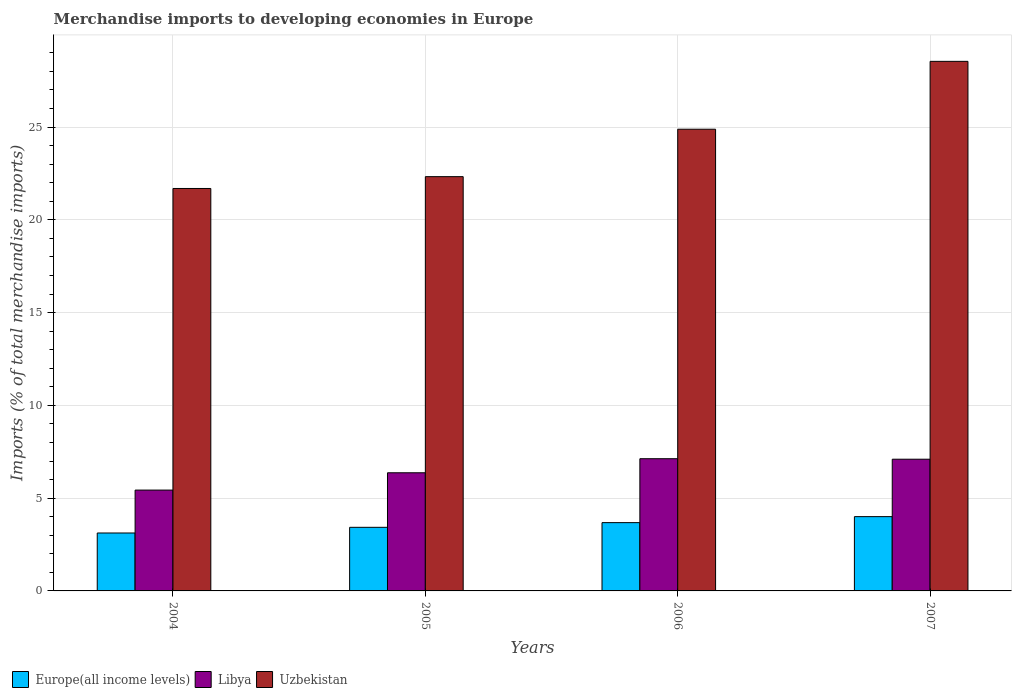How many different coloured bars are there?
Make the answer very short. 3. Are the number of bars per tick equal to the number of legend labels?
Your answer should be very brief. Yes. How many bars are there on the 1st tick from the left?
Your answer should be very brief. 3. What is the label of the 2nd group of bars from the left?
Give a very brief answer. 2005. In how many cases, is the number of bars for a given year not equal to the number of legend labels?
Your answer should be very brief. 0. What is the percentage total merchandise imports in Libya in 2005?
Your response must be concise. 6.37. Across all years, what is the maximum percentage total merchandise imports in Libya?
Offer a very short reply. 7.13. Across all years, what is the minimum percentage total merchandise imports in Libya?
Your answer should be very brief. 5.44. In which year was the percentage total merchandise imports in Uzbekistan maximum?
Offer a very short reply. 2007. In which year was the percentage total merchandise imports in Libya minimum?
Your answer should be compact. 2004. What is the total percentage total merchandise imports in Uzbekistan in the graph?
Your answer should be very brief. 97.45. What is the difference between the percentage total merchandise imports in Libya in 2004 and that in 2005?
Keep it short and to the point. -0.93. What is the difference between the percentage total merchandise imports in Europe(all income levels) in 2006 and the percentage total merchandise imports in Libya in 2004?
Provide a succinct answer. -1.75. What is the average percentage total merchandise imports in Europe(all income levels) per year?
Keep it short and to the point. 3.56. In the year 2006, what is the difference between the percentage total merchandise imports in Uzbekistan and percentage total merchandise imports in Libya?
Your answer should be very brief. 17.76. What is the ratio of the percentage total merchandise imports in Libya in 2005 to that in 2006?
Keep it short and to the point. 0.89. Is the difference between the percentage total merchandise imports in Uzbekistan in 2004 and 2007 greater than the difference between the percentage total merchandise imports in Libya in 2004 and 2007?
Offer a very short reply. No. What is the difference between the highest and the second highest percentage total merchandise imports in Europe(all income levels)?
Keep it short and to the point. 0.32. What is the difference between the highest and the lowest percentage total merchandise imports in Europe(all income levels)?
Make the answer very short. 0.88. In how many years, is the percentage total merchandise imports in Uzbekistan greater than the average percentage total merchandise imports in Uzbekistan taken over all years?
Make the answer very short. 2. Is the sum of the percentage total merchandise imports in Uzbekistan in 2004 and 2005 greater than the maximum percentage total merchandise imports in Europe(all income levels) across all years?
Keep it short and to the point. Yes. What does the 1st bar from the left in 2004 represents?
Your response must be concise. Europe(all income levels). What does the 2nd bar from the right in 2004 represents?
Your response must be concise. Libya. Is it the case that in every year, the sum of the percentage total merchandise imports in Europe(all income levels) and percentage total merchandise imports in Libya is greater than the percentage total merchandise imports in Uzbekistan?
Your answer should be very brief. No. Are all the bars in the graph horizontal?
Offer a very short reply. No. How many years are there in the graph?
Provide a short and direct response. 4. Does the graph contain any zero values?
Your answer should be very brief. No. What is the title of the graph?
Provide a short and direct response. Merchandise imports to developing economies in Europe. What is the label or title of the X-axis?
Give a very brief answer. Years. What is the label or title of the Y-axis?
Your answer should be very brief. Imports (% of total merchandise imports). What is the Imports (% of total merchandise imports) of Europe(all income levels) in 2004?
Provide a short and direct response. 3.12. What is the Imports (% of total merchandise imports) in Libya in 2004?
Give a very brief answer. 5.44. What is the Imports (% of total merchandise imports) of Uzbekistan in 2004?
Offer a terse response. 21.69. What is the Imports (% of total merchandise imports) in Europe(all income levels) in 2005?
Keep it short and to the point. 3.43. What is the Imports (% of total merchandise imports) in Libya in 2005?
Keep it short and to the point. 6.37. What is the Imports (% of total merchandise imports) of Uzbekistan in 2005?
Your response must be concise. 22.33. What is the Imports (% of total merchandise imports) in Europe(all income levels) in 2006?
Keep it short and to the point. 3.68. What is the Imports (% of total merchandise imports) of Libya in 2006?
Provide a short and direct response. 7.13. What is the Imports (% of total merchandise imports) of Uzbekistan in 2006?
Ensure brevity in your answer.  24.88. What is the Imports (% of total merchandise imports) of Europe(all income levels) in 2007?
Give a very brief answer. 4. What is the Imports (% of total merchandise imports) in Libya in 2007?
Keep it short and to the point. 7.1. What is the Imports (% of total merchandise imports) of Uzbekistan in 2007?
Your answer should be very brief. 28.54. Across all years, what is the maximum Imports (% of total merchandise imports) of Europe(all income levels)?
Offer a very short reply. 4. Across all years, what is the maximum Imports (% of total merchandise imports) of Libya?
Ensure brevity in your answer.  7.13. Across all years, what is the maximum Imports (% of total merchandise imports) of Uzbekistan?
Make the answer very short. 28.54. Across all years, what is the minimum Imports (% of total merchandise imports) of Europe(all income levels)?
Make the answer very short. 3.12. Across all years, what is the minimum Imports (% of total merchandise imports) in Libya?
Keep it short and to the point. 5.44. Across all years, what is the minimum Imports (% of total merchandise imports) in Uzbekistan?
Make the answer very short. 21.69. What is the total Imports (% of total merchandise imports) in Europe(all income levels) in the graph?
Offer a terse response. 14.23. What is the total Imports (% of total merchandise imports) in Libya in the graph?
Offer a very short reply. 26.03. What is the total Imports (% of total merchandise imports) of Uzbekistan in the graph?
Provide a short and direct response. 97.45. What is the difference between the Imports (% of total merchandise imports) in Europe(all income levels) in 2004 and that in 2005?
Offer a very short reply. -0.31. What is the difference between the Imports (% of total merchandise imports) of Libya in 2004 and that in 2005?
Keep it short and to the point. -0.93. What is the difference between the Imports (% of total merchandise imports) of Uzbekistan in 2004 and that in 2005?
Give a very brief answer. -0.64. What is the difference between the Imports (% of total merchandise imports) of Europe(all income levels) in 2004 and that in 2006?
Make the answer very short. -0.56. What is the difference between the Imports (% of total merchandise imports) of Libya in 2004 and that in 2006?
Offer a terse response. -1.69. What is the difference between the Imports (% of total merchandise imports) of Uzbekistan in 2004 and that in 2006?
Offer a terse response. -3.19. What is the difference between the Imports (% of total merchandise imports) of Europe(all income levels) in 2004 and that in 2007?
Keep it short and to the point. -0.88. What is the difference between the Imports (% of total merchandise imports) of Libya in 2004 and that in 2007?
Your answer should be very brief. -1.66. What is the difference between the Imports (% of total merchandise imports) of Uzbekistan in 2004 and that in 2007?
Provide a succinct answer. -6.85. What is the difference between the Imports (% of total merchandise imports) in Europe(all income levels) in 2005 and that in 2006?
Offer a terse response. -0.25. What is the difference between the Imports (% of total merchandise imports) of Libya in 2005 and that in 2006?
Ensure brevity in your answer.  -0.76. What is the difference between the Imports (% of total merchandise imports) in Uzbekistan in 2005 and that in 2006?
Offer a terse response. -2.56. What is the difference between the Imports (% of total merchandise imports) of Europe(all income levels) in 2005 and that in 2007?
Keep it short and to the point. -0.58. What is the difference between the Imports (% of total merchandise imports) of Libya in 2005 and that in 2007?
Make the answer very short. -0.73. What is the difference between the Imports (% of total merchandise imports) in Uzbekistan in 2005 and that in 2007?
Offer a very short reply. -6.21. What is the difference between the Imports (% of total merchandise imports) in Europe(all income levels) in 2006 and that in 2007?
Your answer should be compact. -0.32. What is the difference between the Imports (% of total merchandise imports) in Libya in 2006 and that in 2007?
Offer a terse response. 0.03. What is the difference between the Imports (% of total merchandise imports) of Uzbekistan in 2006 and that in 2007?
Your response must be concise. -3.66. What is the difference between the Imports (% of total merchandise imports) of Europe(all income levels) in 2004 and the Imports (% of total merchandise imports) of Libya in 2005?
Give a very brief answer. -3.25. What is the difference between the Imports (% of total merchandise imports) of Europe(all income levels) in 2004 and the Imports (% of total merchandise imports) of Uzbekistan in 2005?
Give a very brief answer. -19.21. What is the difference between the Imports (% of total merchandise imports) in Libya in 2004 and the Imports (% of total merchandise imports) in Uzbekistan in 2005?
Provide a short and direct response. -16.89. What is the difference between the Imports (% of total merchandise imports) of Europe(all income levels) in 2004 and the Imports (% of total merchandise imports) of Libya in 2006?
Offer a terse response. -4. What is the difference between the Imports (% of total merchandise imports) of Europe(all income levels) in 2004 and the Imports (% of total merchandise imports) of Uzbekistan in 2006?
Provide a succinct answer. -21.76. What is the difference between the Imports (% of total merchandise imports) of Libya in 2004 and the Imports (% of total merchandise imports) of Uzbekistan in 2006?
Give a very brief answer. -19.45. What is the difference between the Imports (% of total merchandise imports) in Europe(all income levels) in 2004 and the Imports (% of total merchandise imports) in Libya in 2007?
Ensure brevity in your answer.  -3.98. What is the difference between the Imports (% of total merchandise imports) of Europe(all income levels) in 2004 and the Imports (% of total merchandise imports) of Uzbekistan in 2007?
Give a very brief answer. -25.42. What is the difference between the Imports (% of total merchandise imports) in Libya in 2004 and the Imports (% of total merchandise imports) in Uzbekistan in 2007?
Give a very brief answer. -23.11. What is the difference between the Imports (% of total merchandise imports) of Europe(all income levels) in 2005 and the Imports (% of total merchandise imports) of Libya in 2006?
Give a very brief answer. -3.7. What is the difference between the Imports (% of total merchandise imports) of Europe(all income levels) in 2005 and the Imports (% of total merchandise imports) of Uzbekistan in 2006?
Make the answer very short. -21.46. What is the difference between the Imports (% of total merchandise imports) in Libya in 2005 and the Imports (% of total merchandise imports) in Uzbekistan in 2006?
Provide a short and direct response. -18.52. What is the difference between the Imports (% of total merchandise imports) in Europe(all income levels) in 2005 and the Imports (% of total merchandise imports) in Libya in 2007?
Ensure brevity in your answer.  -3.67. What is the difference between the Imports (% of total merchandise imports) of Europe(all income levels) in 2005 and the Imports (% of total merchandise imports) of Uzbekistan in 2007?
Make the answer very short. -25.11. What is the difference between the Imports (% of total merchandise imports) in Libya in 2005 and the Imports (% of total merchandise imports) in Uzbekistan in 2007?
Give a very brief answer. -22.17. What is the difference between the Imports (% of total merchandise imports) of Europe(all income levels) in 2006 and the Imports (% of total merchandise imports) of Libya in 2007?
Offer a terse response. -3.42. What is the difference between the Imports (% of total merchandise imports) of Europe(all income levels) in 2006 and the Imports (% of total merchandise imports) of Uzbekistan in 2007?
Provide a succinct answer. -24.86. What is the difference between the Imports (% of total merchandise imports) in Libya in 2006 and the Imports (% of total merchandise imports) in Uzbekistan in 2007?
Ensure brevity in your answer.  -21.42. What is the average Imports (% of total merchandise imports) of Europe(all income levels) per year?
Make the answer very short. 3.56. What is the average Imports (% of total merchandise imports) in Libya per year?
Keep it short and to the point. 6.51. What is the average Imports (% of total merchandise imports) of Uzbekistan per year?
Provide a succinct answer. 24.36. In the year 2004, what is the difference between the Imports (% of total merchandise imports) of Europe(all income levels) and Imports (% of total merchandise imports) of Libya?
Your answer should be very brief. -2.31. In the year 2004, what is the difference between the Imports (% of total merchandise imports) of Europe(all income levels) and Imports (% of total merchandise imports) of Uzbekistan?
Make the answer very short. -18.57. In the year 2004, what is the difference between the Imports (% of total merchandise imports) of Libya and Imports (% of total merchandise imports) of Uzbekistan?
Provide a short and direct response. -16.26. In the year 2005, what is the difference between the Imports (% of total merchandise imports) in Europe(all income levels) and Imports (% of total merchandise imports) in Libya?
Keep it short and to the point. -2.94. In the year 2005, what is the difference between the Imports (% of total merchandise imports) of Europe(all income levels) and Imports (% of total merchandise imports) of Uzbekistan?
Offer a very short reply. -18.9. In the year 2005, what is the difference between the Imports (% of total merchandise imports) of Libya and Imports (% of total merchandise imports) of Uzbekistan?
Keep it short and to the point. -15.96. In the year 2006, what is the difference between the Imports (% of total merchandise imports) in Europe(all income levels) and Imports (% of total merchandise imports) in Libya?
Your answer should be compact. -3.44. In the year 2006, what is the difference between the Imports (% of total merchandise imports) of Europe(all income levels) and Imports (% of total merchandise imports) of Uzbekistan?
Provide a succinct answer. -21.2. In the year 2006, what is the difference between the Imports (% of total merchandise imports) of Libya and Imports (% of total merchandise imports) of Uzbekistan?
Make the answer very short. -17.76. In the year 2007, what is the difference between the Imports (% of total merchandise imports) of Europe(all income levels) and Imports (% of total merchandise imports) of Libya?
Your response must be concise. -3.09. In the year 2007, what is the difference between the Imports (% of total merchandise imports) in Europe(all income levels) and Imports (% of total merchandise imports) in Uzbekistan?
Make the answer very short. -24.54. In the year 2007, what is the difference between the Imports (% of total merchandise imports) of Libya and Imports (% of total merchandise imports) of Uzbekistan?
Keep it short and to the point. -21.44. What is the ratio of the Imports (% of total merchandise imports) in Europe(all income levels) in 2004 to that in 2005?
Provide a short and direct response. 0.91. What is the ratio of the Imports (% of total merchandise imports) in Libya in 2004 to that in 2005?
Offer a very short reply. 0.85. What is the ratio of the Imports (% of total merchandise imports) in Uzbekistan in 2004 to that in 2005?
Make the answer very short. 0.97. What is the ratio of the Imports (% of total merchandise imports) in Europe(all income levels) in 2004 to that in 2006?
Provide a succinct answer. 0.85. What is the ratio of the Imports (% of total merchandise imports) in Libya in 2004 to that in 2006?
Your answer should be very brief. 0.76. What is the ratio of the Imports (% of total merchandise imports) of Uzbekistan in 2004 to that in 2006?
Provide a short and direct response. 0.87. What is the ratio of the Imports (% of total merchandise imports) of Europe(all income levels) in 2004 to that in 2007?
Ensure brevity in your answer.  0.78. What is the ratio of the Imports (% of total merchandise imports) in Libya in 2004 to that in 2007?
Keep it short and to the point. 0.77. What is the ratio of the Imports (% of total merchandise imports) in Uzbekistan in 2004 to that in 2007?
Make the answer very short. 0.76. What is the ratio of the Imports (% of total merchandise imports) in Europe(all income levels) in 2005 to that in 2006?
Your answer should be very brief. 0.93. What is the ratio of the Imports (% of total merchandise imports) in Libya in 2005 to that in 2006?
Provide a short and direct response. 0.89. What is the ratio of the Imports (% of total merchandise imports) in Uzbekistan in 2005 to that in 2006?
Keep it short and to the point. 0.9. What is the ratio of the Imports (% of total merchandise imports) of Europe(all income levels) in 2005 to that in 2007?
Your response must be concise. 0.86. What is the ratio of the Imports (% of total merchandise imports) of Libya in 2005 to that in 2007?
Ensure brevity in your answer.  0.9. What is the ratio of the Imports (% of total merchandise imports) of Uzbekistan in 2005 to that in 2007?
Ensure brevity in your answer.  0.78. What is the ratio of the Imports (% of total merchandise imports) of Europe(all income levels) in 2006 to that in 2007?
Make the answer very short. 0.92. What is the ratio of the Imports (% of total merchandise imports) of Uzbekistan in 2006 to that in 2007?
Your response must be concise. 0.87. What is the difference between the highest and the second highest Imports (% of total merchandise imports) in Europe(all income levels)?
Your answer should be very brief. 0.32. What is the difference between the highest and the second highest Imports (% of total merchandise imports) in Libya?
Your response must be concise. 0.03. What is the difference between the highest and the second highest Imports (% of total merchandise imports) of Uzbekistan?
Your response must be concise. 3.66. What is the difference between the highest and the lowest Imports (% of total merchandise imports) in Europe(all income levels)?
Make the answer very short. 0.88. What is the difference between the highest and the lowest Imports (% of total merchandise imports) of Libya?
Your response must be concise. 1.69. What is the difference between the highest and the lowest Imports (% of total merchandise imports) of Uzbekistan?
Your answer should be compact. 6.85. 